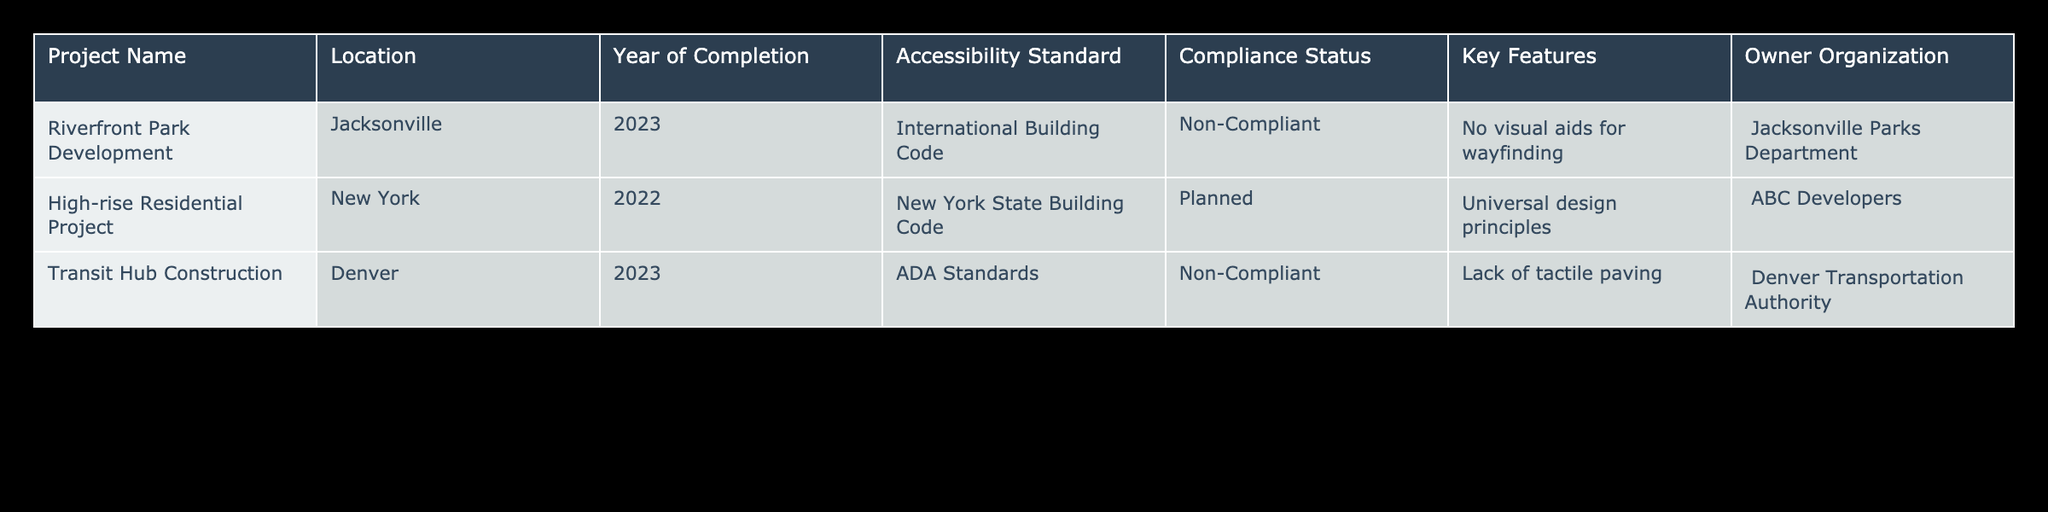What is the compliance status of the Riverfront Park Development project? The compliance status for Riverfront Park Development is listed in the table under the "Compliance Status" column. It clearly states "Non-Compliant."
Answer: Non-Compliant How many projects are planned according to the table? By scanning the "Compliance Status" column, we can identify that the only project marked as "Planned" is the High-rise Residential Project. Thus, there is one planned project.
Answer: 1 Which organization owns the Transit Hub Construction project? The "Owner Organization" column provides information about the ownership of each project. For the Transit Hub Construction, it states "Denver Transportation Authority."
Answer: Denver Transportation Authority Are there any projects compliant with the ADA Standards? The table indicates that the Transit Hub Construction project, which pertains to the ADA Standards, has a compliance status of "Non-Compliant." Therefore, there are no compliant projects related to the ADA Standards.
Answer: No What year did the High-rise Residential Project complete, and what is its accessibility standard? The table shows that the High-rise Residential Project was completed in 2022, and its specified accessibility standard is the "New York State Building Code."
Answer: 2022, New York State Building Code How many projects are non-compliant, and what are their names? By reviewing the "Compliance Status" column, we see that Riverfront Park Development and Transit Hub Construction are marked as "Non-Compliant," which totals to two projects. Their names are provided in the "Project Name" column.
Answer: 2, Riverfront Park Development; Transit Hub Construction What key feature is missing in the Transit Hub Construction project? According to the "Key Features" column corresponding to the Transit Hub Construction project, the table mentions "Lack of tactile paving." This detail points out the aspect that is not included in the project.
Answer: Lack of tactile paving Which accessibility standard has the most recent year of completion among the projects listed? The most recent project is the Riverfront Park Development, completed in 2023, under the International Building Code. Comparing the years, 2023 is the latest.
Answer: International Building Code (2023) What are the key features of the High-rise Residential Project? The table entry for the High-rise Residential Project under "Key Features" states "Universal design principles." This highlights the aim of including diverse user needs in its design.
Answer: Universal design principles 